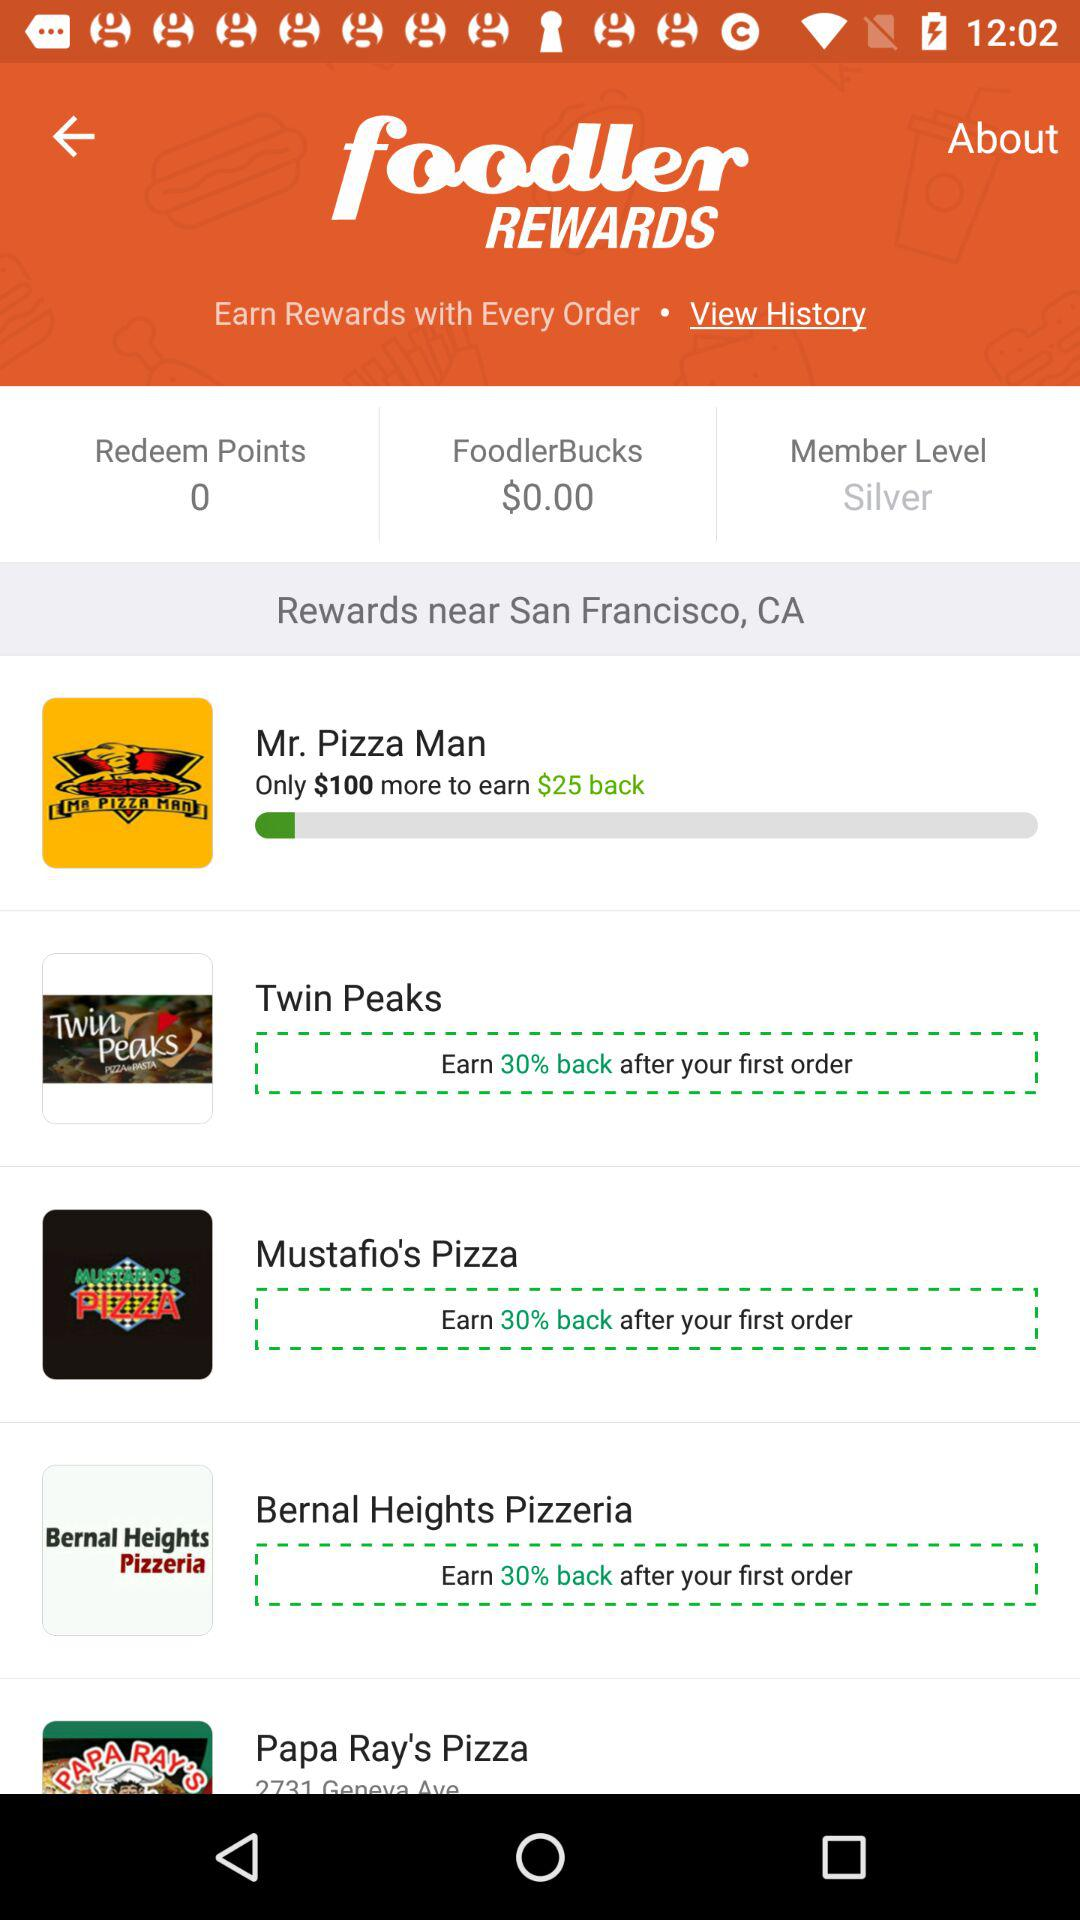How much reward can be earned after the first order on "Twin Peaks"? You can earn 30% back after the first order on "Twin Peaks". 